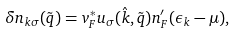Convert formula to latex. <formula><loc_0><loc_0><loc_500><loc_500>\delta n _ { { k } \sigma } ( \tilde { q } ) = v _ { F } ^ { * } u _ { \sigma } ( { \hat { k } } , \tilde { q } ) n _ { F } ^ { \prime } ( \epsilon _ { k } - \mu ) ,</formula> 